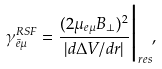<formula> <loc_0><loc_0><loc_500><loc_500>\gamma _ { \bar { e } \mu } ^ { R S F } = \frac { ( 2 \mu _ { e \mu } B _ { \perp } ) ^ { 2 } } { | d \Delta V / d r | } \Big | _ { r e s } ,</formula> 